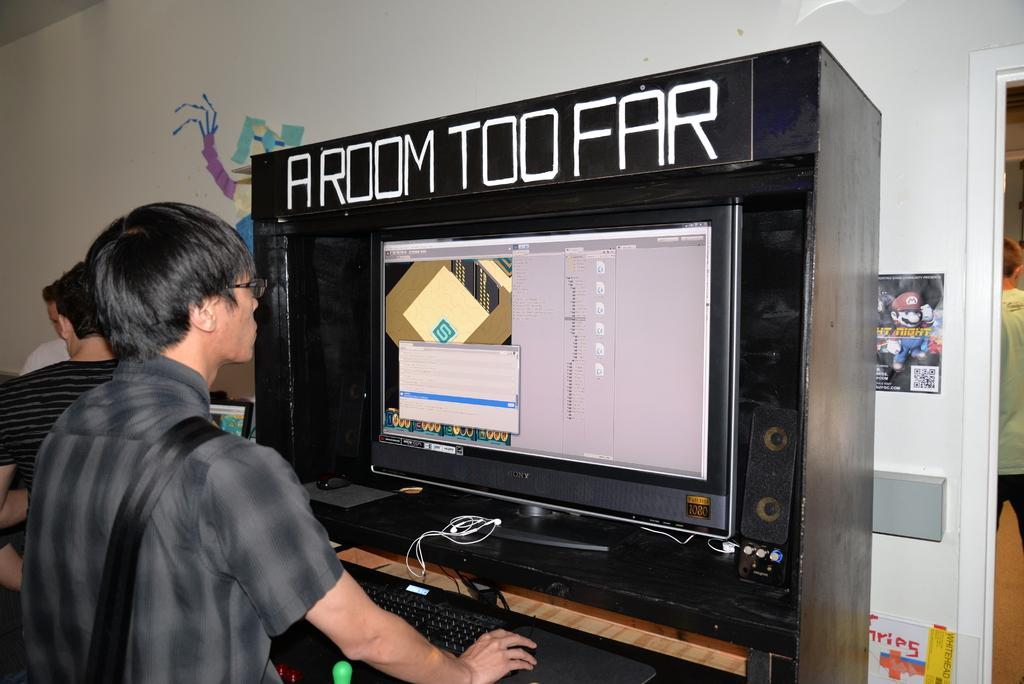Provide a one-sentence caption for the provided image. A video game is labeled A Room Too Far. 